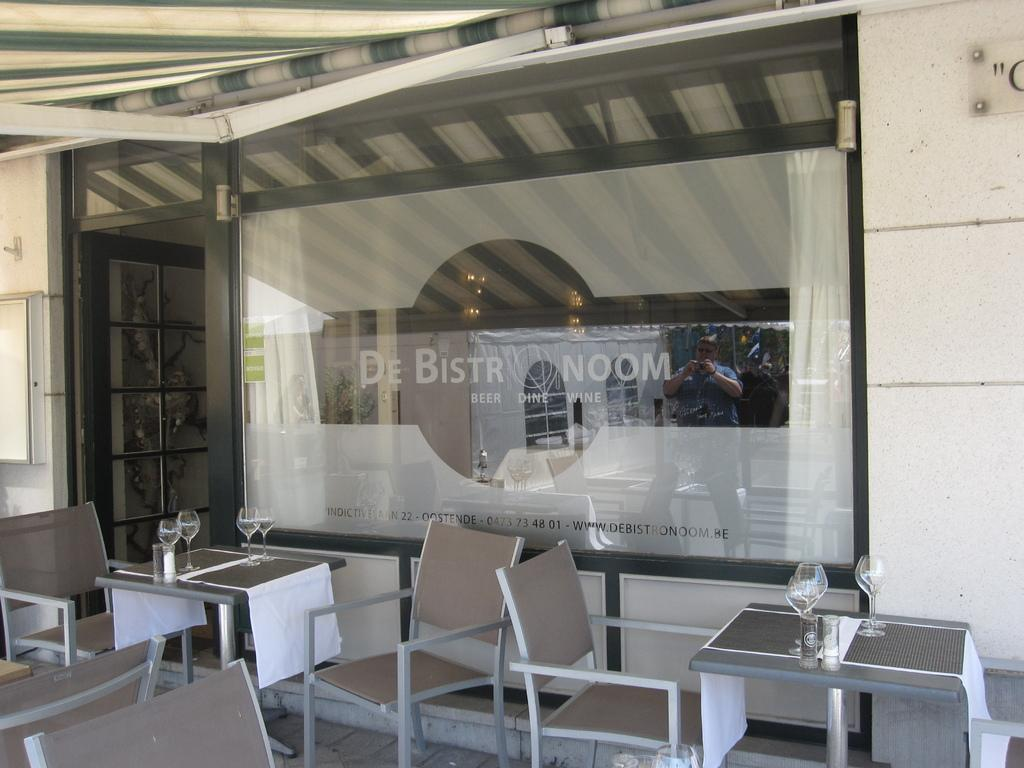<image>
Relay a brief, clear account of the picture shown. outside covered dining area of de bistro noom 